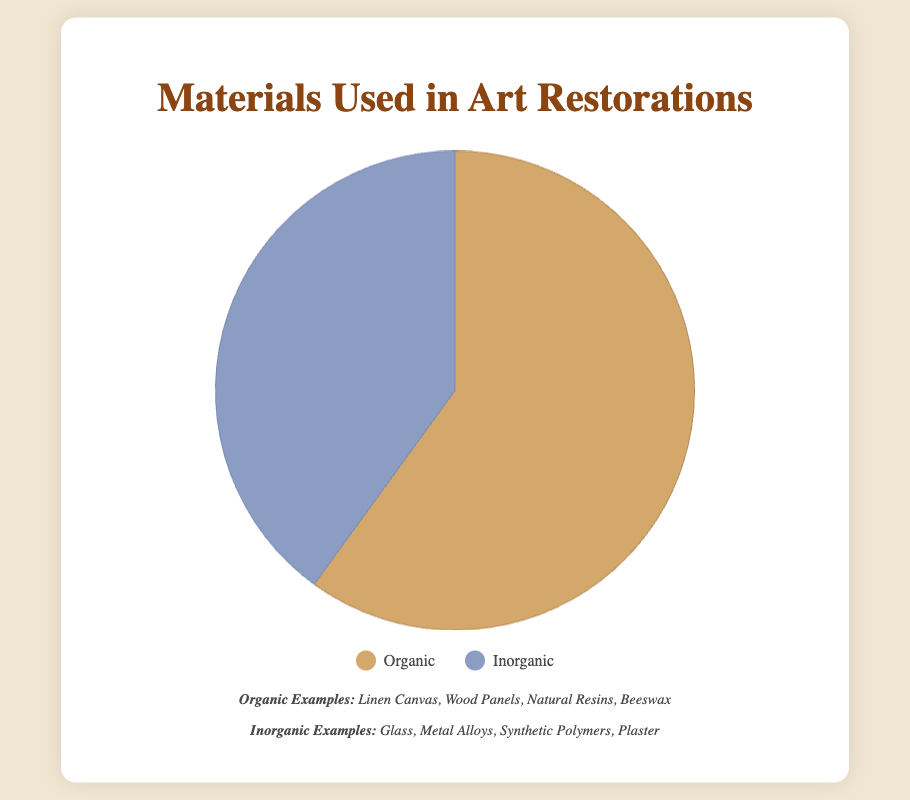What are the two types of materials used in art restorations represented in the pie chart? The pie chart shows two types of materials: "Organic" and "Inorganic". You can determine this by looking at the legend provided.
Answer: Organic and Inorganic What percentage of materials used in restorations are organic? By looking at the pie chart's dataset, you can see that 60% of the materials used in restorations are organic.
Answer: 60% Which type of material is used more frequently in restorations? Comparing the pie slices visually, the organic slice is larger than the inorganic slice. From the data, we see that organic materials make up 60% and inorganic materials make up 40%. Therefore, organic materials are used more frequently.
Answer: Organic How much more frequently are organic materials used in restorations compared to inorganic materials? Subtract the percentage of inorganic materials from the percentage of organic materials: 60% (organic) − 40% (inorganic) = 20%.
Answer: 20% What are some examples of inorganic materials used in restorations? The examples provided under the Inorganic category are: "Glass", "Metal Alloys", "Synthetic Polymers", and "Plaster".
Answer: Glass, Metal Alloys, Synthetic Polymers, Plaster By how much do organic materials exceed inorganic materials in their usage percentage? Calculate the difference between organic and inorganic materials' usage percentages. 60% (Organic) – 40% (Inorganic) = 20%.
Answer: 20% What is the combined percentage of organic and inorganic materials used in restorations? Sum the percentages of both types of materials: 60% (Organic) + 40% (Inorganic) = 100%.
Answer: 100% What color represents organic materials in the pie chart? By referring to the legend, the color for organic materials is shown as a shade of brown.
Answer: Brown If the organic materials usage was reduced by half, what would the new usage percentage be? If the organic usage was reduced by half, you would take half of 60%, which is 30%.
Answer: 30% What is the average usage percentage of both types of materials used in restorations? The average usage percentage can be calculated by summing both percentages and dividing by 2. (60% + 40%) / 2 = 50%.
Answer: 50% 